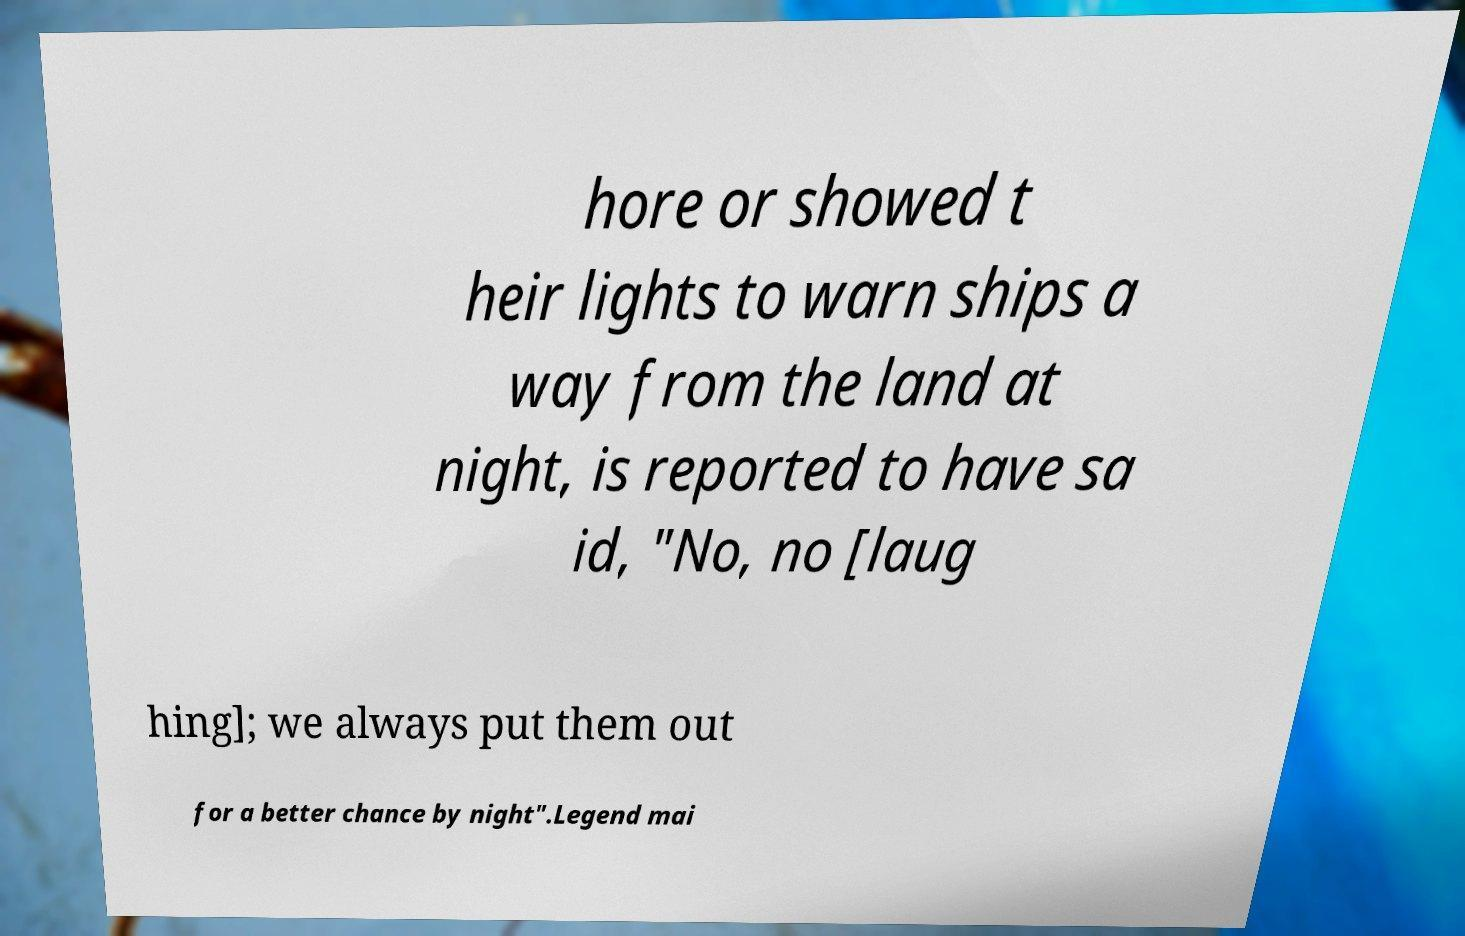Could you assist in decoding the text presented in this image and type it out clearly? hore or showed t heir lights to warn ships a way from the land at night, is reported to have sa id, "No, no [laug hing]; we always put them out for a better chance by night".Legend mai 